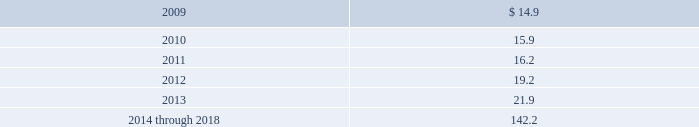Estimated future pension benefit payments for the next ten years under the plan ( in millions ) are as follows : estimated future payments: .
Bfi post retirement healthcare plan we acquired obligations under the bfi post retirement healthcare plan as part of our acquisition of allied .
This plan provides continued medical coverage for certain former employees following their retirement , including some employees subject to collective bargaining agreements .
Eligibility for this plan is limited to certain of those employees who had ten or more years of service and were age 55 or older as of december 31 , 1998 , and certain employees in california who were hired on or before december 31 , 2005 and who retire on or after age 55 with at least thirty years of service .
Liabilities acquired for this plan were $ 1.2 million and $ 1.3 million , respectively , at the acquisition date and at december 31 , 2008 .
Multi-employer pension plans we contribute to 25 multi-employer pension plans under collective bargaining agreements covering union- represented employees .
We acquired responsibility for contributions for a portion of these plans as part of our acquisition of allied .
Approximately 22% ( 22 % ) of our total current employees are participants in such multi- employer plans .
These plans generally provide retirement benefits to participants based on their service to contributing employers .
We do not administer these multi-employer plans .
In general , these plans are managed by a board of trustees with the unions appointing certain trustees and other contributing employers of the plan appointing certain members .
We generally are not represented on the board of trustees .
We do not have current plan financial information from the plans 2019 administrators , but based on the information available to us , it is possible that some of the multi-employer plans to which we contribute may be underfunded .
The pension protection act , enacted in august 2006 , requires underfunded pension plans to improve their funding ratios within prescribed intervals based on the level of their underfunding .
Until the plan trustees develop the funding improvement plans or rehabilitation plans as required by the pension protection act , we are unable to determine the amount of assessments we may be subject to , if any .
Accordingly , we cannot determine at this time the impact that the pension protection act may have on our consolidated financial position , results of operations or cash flows .
Furthermore , under current law regarding multi-employer benefit plans , a plan 2019s termination , our voluntary withdrawal , or the mass withdrawal of all contributing employers from any under-funded , multi-employer pension plan would require us to make payments to the plan for our proportionate share of the multi- employer plan 2019s unfunded vested liabilities .
It is possible that there may be a mass withdrawal of employers contributing to these plans or plans may terminate in the near future .
We could have adjustments to our estimates for these matters in the near term that could have a material effect on our consolidated financial condition , results of operations or cash flows .
Our pension expense for multi-employer plans was $ 21.8 million , $ 18.9 million and $ 17.3 million for the years ended december 31 , 2008 , 2007 and 2006 , respectively .
Republic services , inc .
And subsidiaries notes to consolidated financial statements %%transmsg*** transmitting job : p14076 pcn : 133000000 ***%%pcmsg|131 |00027|yes|no|02/28/2009 21:12|0|0|page is valid , no graphics -- color : d| .
At december 312008 what was the total liabilities acquired for this plan in millions? 
Rationale: the total liabilities is the sum of the amounts as shown above
Computations: (1.3 + 1.2)
Answer: 2.5. 